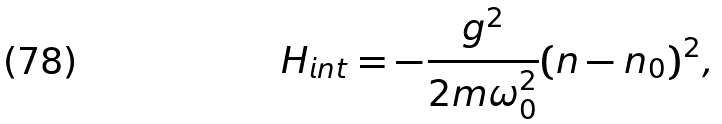Convert formula to latex. <formula><loc_0><loc_0><loc_500><loc_500>H _ { i n t } = - \frac { g ^ { 2 } } { 2 m \omega _ { 0 } ^ { 2 } } ( n - n _ { 0 } ) ^ { 2 } ,</formula> 